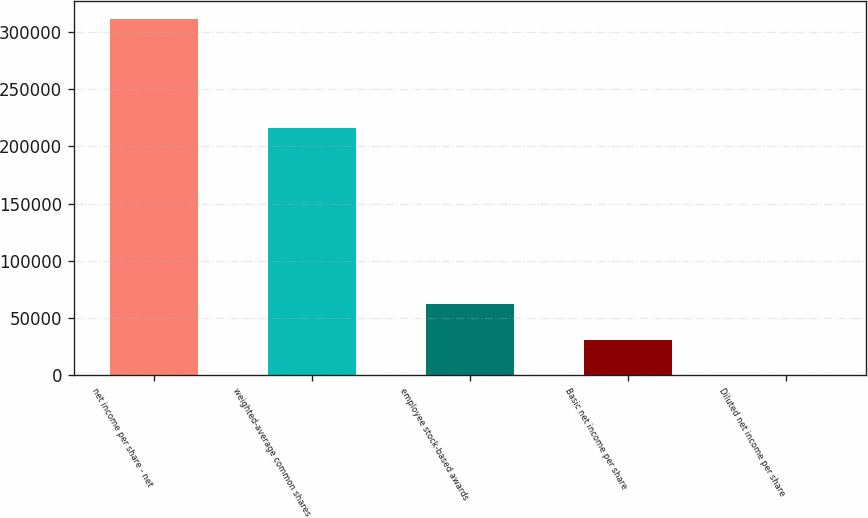Convert chart. <chart><loc_0><loc_0><loc_500><loc_500><bar_chart><fcel>net income per share - net<fcel>weighted-average common shares<fcel>employee stock-based awards<fcel>Basic net income per share<fcel>Diluted net income per share<nl><fcel>311219<fcel>216294<fcel>62244.9<fcel>31123.2<fcel>1.43<nl></chart> 